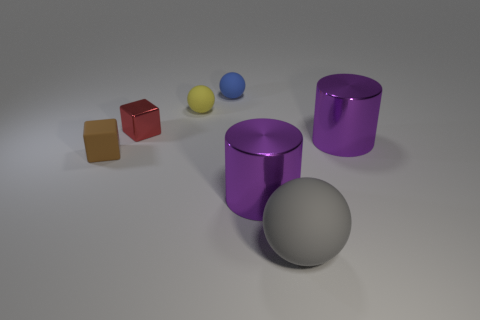Subtract all tiny blue balls. How many balls are left? 2 Subtract all cylinders. How many objects are left? 5 Add 1 yellow rubber spheres. How many objects exist? 8 Subtract all yellow spheres. How many spheres are left? 2 Subtract 1 cylinders. How many cylinders are left? 1 Subtract all brown balls. Subtract all gray cubes. How many balls are left? 3 Subtract all tiny brown matte objects. Subtract all big metallic cylinders. How many objects are left? 4 Add 2 gray things. How many gray things are left? 3 Add 7 brown metallic things. How many brown metallic things exist? 7 Subtract 0 cyan cylinders. How many objects are left? 7 